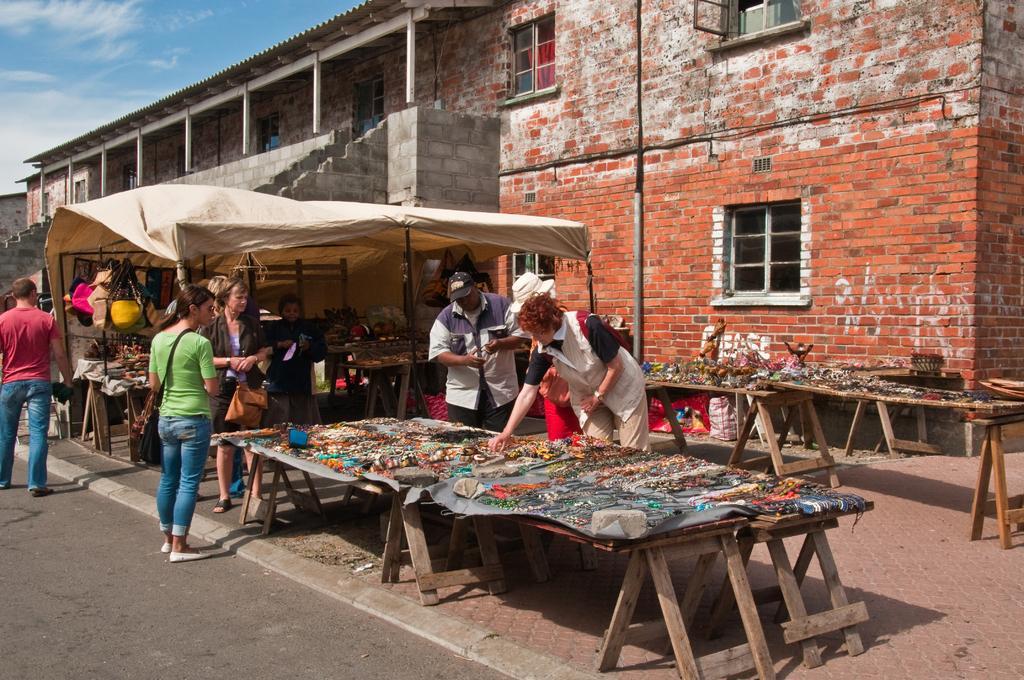Could you give a brief overview of what you see in this image? This is a street view. Many people are standing. Woman wearing a green t shirt is holding a bag. And there are benches. On the benches there are many items. Behind the bench three persons are standing wearing a hat and a cap. In the background there is a building with brick wall and windows. Also there is a tent. Inside the tent there are some bags hanged on the wall. 